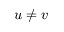<formula> <loc_0><loc_0><loc_500><loc_500>u \ne v</formula> 